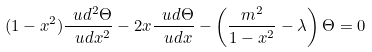Convert formula to latex. <formula><loc_0><loc_0><loc_500><loc_500>( 1 - x ^ { 2 } ) \frac { \ u d ^ { 2 } \Theta } { \ u d x ^ { 2 } } - 2 x \frac { \ u d \Theta } { \ u d x } - \left ( \frac { m ^ { 2 } } { 1 - x ^ { 2 } } - \lambda \right ) \Theta = 0</formula> 